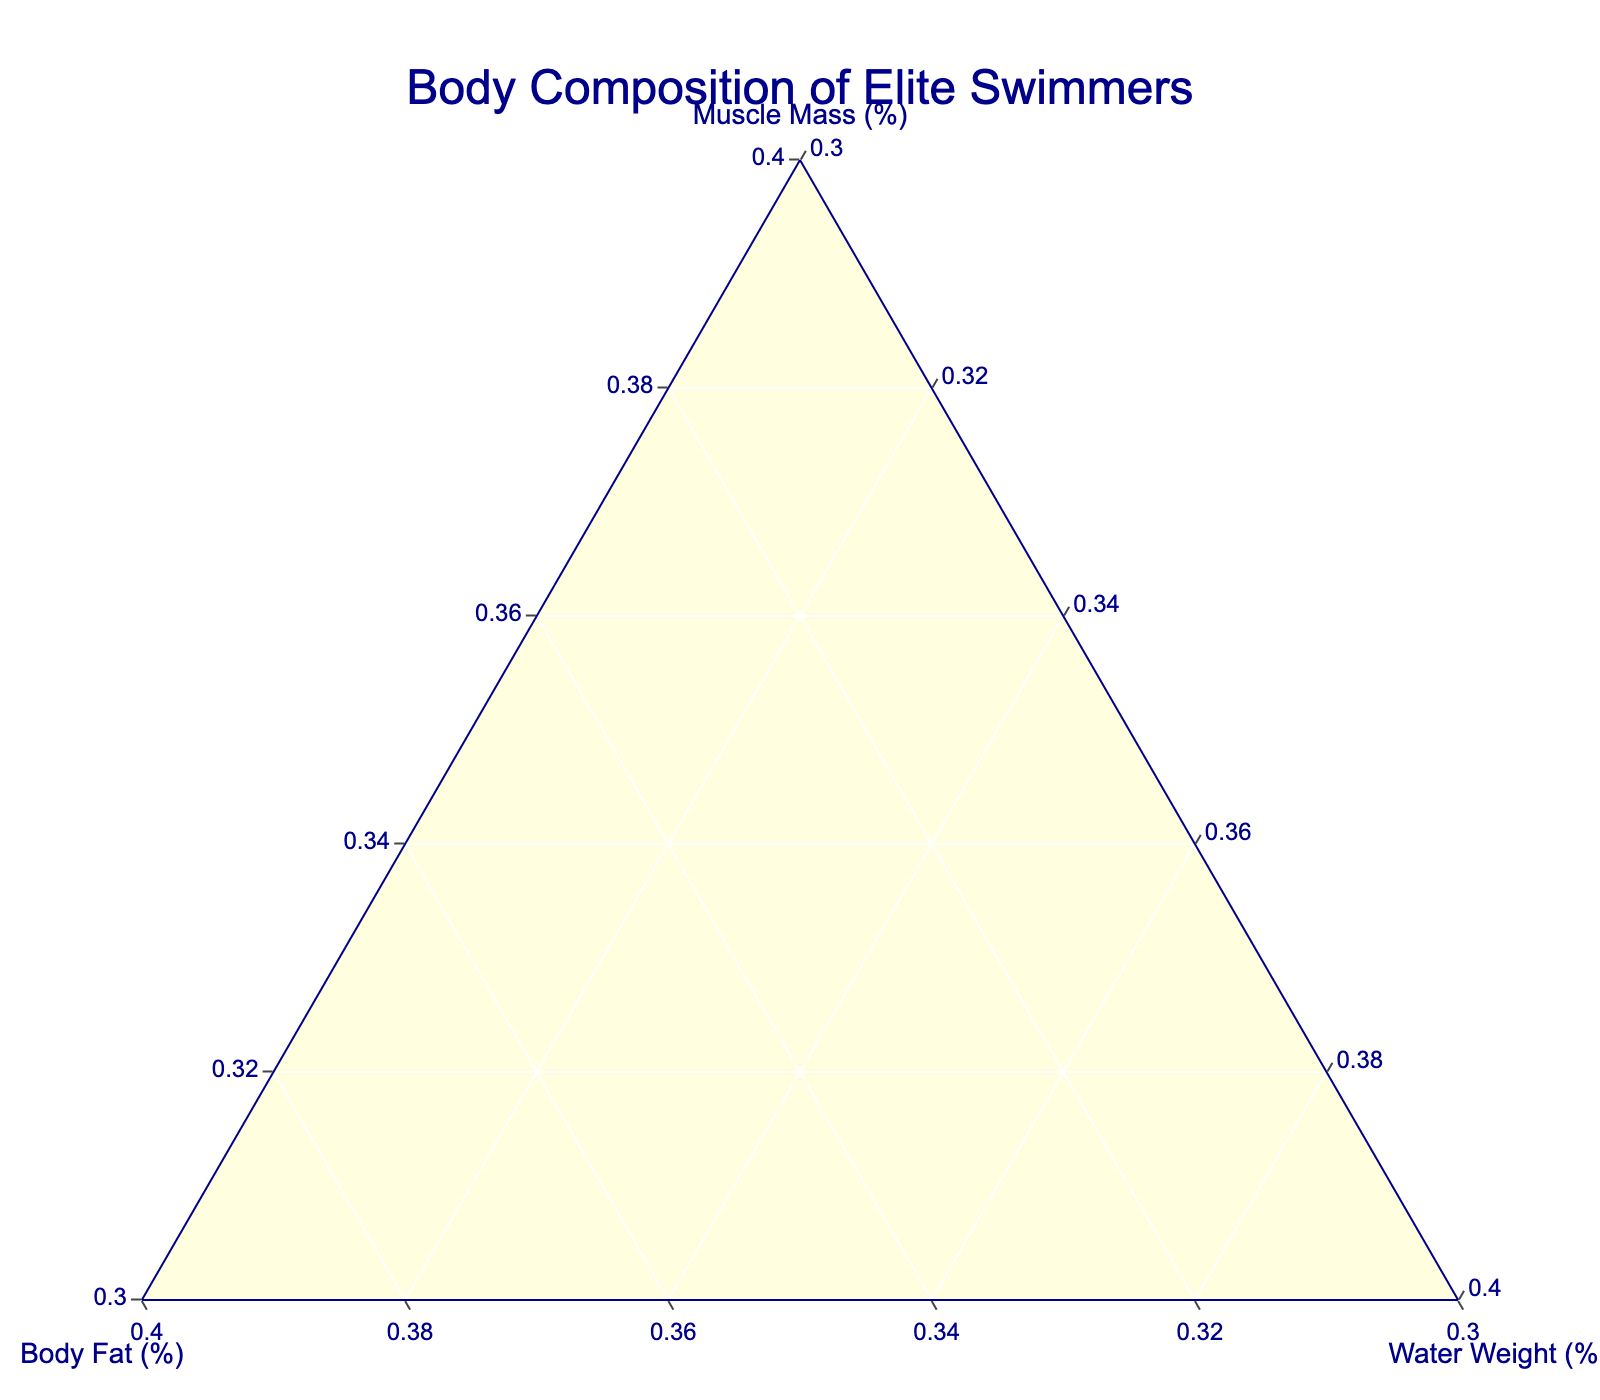What are the three categories shown in the ternary plot? The ternary plot shows the composition of three categories: Muscle Mass (%), Body Fat (%), and Water Weight (%). These categories form the ternary plot axes.
Answer: Muscle Mass (%), Body Fat (%), Water Weight (%) How many swimmers have muscle mass percentages greater than 55%? By visually inspecting the plot, we can count the markers positioned towards the “Muscle Mass (%)” axis with values above 55%. Michael Phelps, Caeleb Dressel, Adam Peaty, Florent Manaudou, and Nathan Adrian all have muscle mass greater than 55%.
Answer: Five swimmers Which swimmer has the highest body fat percentage? To determine the swimmer with the highest body fat percentage, we locate the marker farthest towards the Body Fat (%) axis. Katinka Hosszu and Ranomi Kromowidjojo, both with 13% body fat, represent this maximum value.
Answer: Katinka Hosszu and Ranomi Kromowidjojo Are there any swimmers with equal body composition in terms of muscle mass, body fat, and water weight? We need to look for markers that are positioned at the same point in the ternary plot, which indicates equal composition of muscle mass, body fat, and water weight among swimmers. None of the markers overlap, so no swimmers have exactly the same composition.
Answer: No Which swimmer has the least water weight percentage and what is that percentage? By determining the marker that is closest towards the "Water Weight (%)" axis minimum, we identify that Caeleb Dressel has the least water weight percentage among the swimmers, which is 36%.
Answer: Caeleb Dressel, 36% Compare the body fat percentage of Sarah Sjostrom and Katie Ledecky. Who has a higher percentage and by how much? By comparing their positions on the plot, Sarah Sjostrom has a body fat percentage of 12%, and Katie Ledecky has 10%. To determine the difference: 12% - 10% = 2%.
Answer: Sarah Sjostrom, 2% What's the average muscle mass percentage of swimmers with body fat percentage less than 8%? First, identify swimmers with body fat percentages of Caeleb Dressel (6%), Florent Manaudou (6%), Adam Peaty (7%), Nathan Adrian (7%), and Michael Phelps (7%). Then calculate the average muscle mass: (58% + 57% + 56% + 56% + 55%) / 5 = 282% / 5 = 56.4%.
Answer: 56.4% What is the range of water weight percentages among the swimmers? By observing the minimum and maximum markers along the water weight axis, the water weight values range from 36% to 38%. The difference between the maximum and minimum values is 38% - 36% = 2%.
Answer: 2% Which pair of swimmers have the closest body composition values? We must find two markers that are closest to each other in the ternary plot. Penny Oleksiak and Simone Manuel both have muscle mass of 51%, body fat of 11%, and water weight of 38%, making their compositions very close.
Answer: Penny Oleksiak and Simone Manuel 